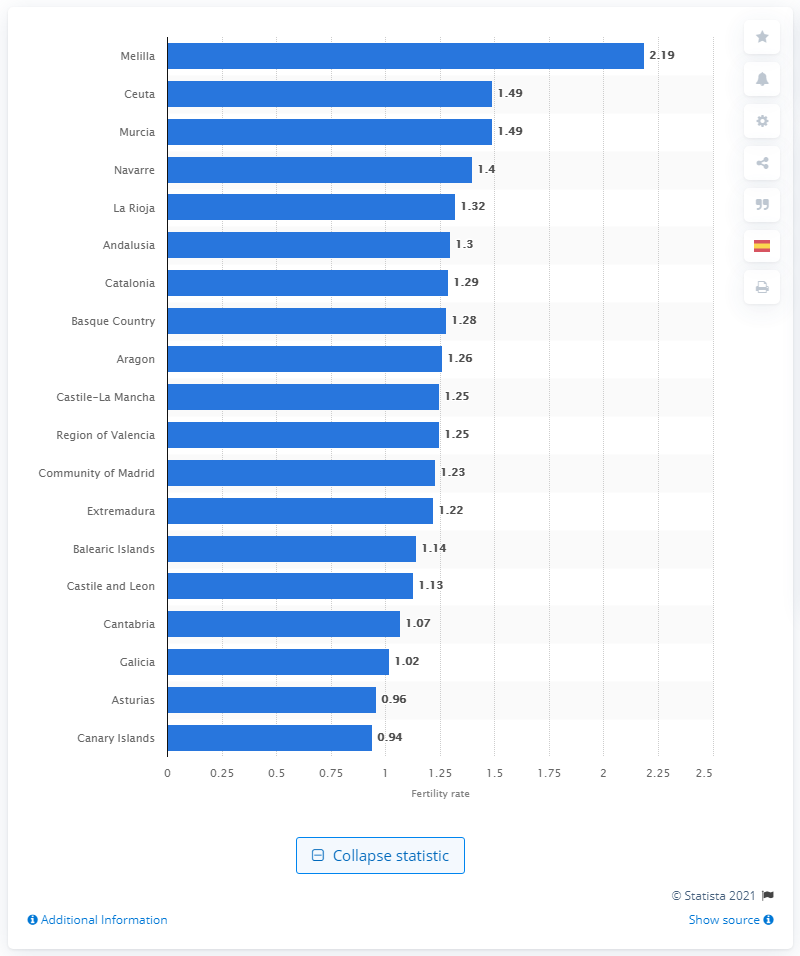Identify some key points in this picture. The average fertility rate per woman in Melilla is 2.19 children. 